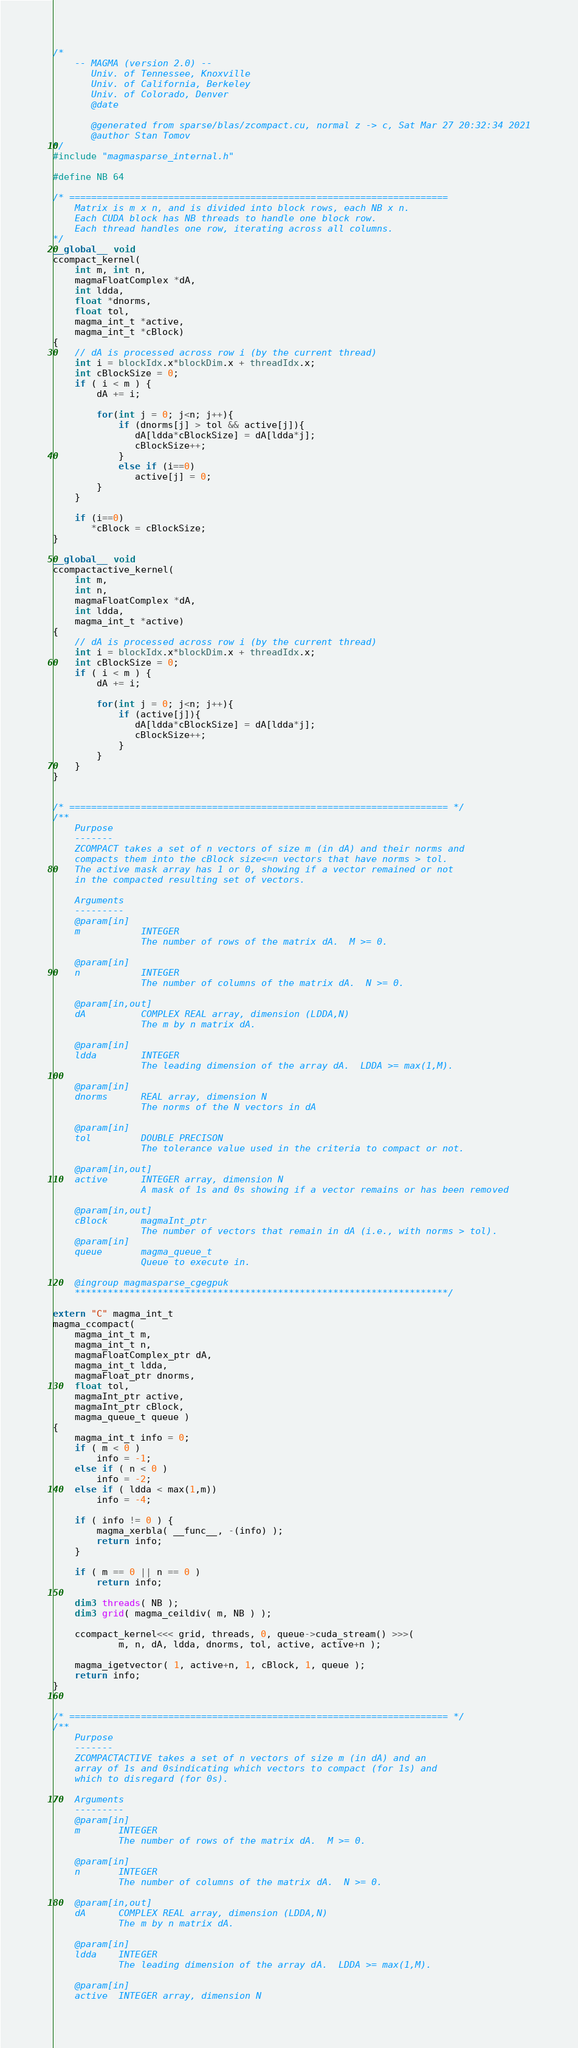<code> <loc_0><loc_0><loc_500><loc_500><_Cuda_>/*
    -- MAGMA (version 2.0) --
       Univ. of Tennessee, Knoxville
       Univ. of California, Berkeley
       Univ. of Colorado, Denver
       @date

       @generated from sparse/blas/zcompact.cu, normal z -> c, Sat Mar 27 20:32:34 2021
       @author Stan Tomov
*/
#include "magmasparse_internal.h"

#define NB 64

/* =====================================================================
    Matrix is m x n, and is divided into block rows, each NB x n.
    Each CUDA block has NB threads to handle one block row.
    Each thread handles one row, iterating across all columns.
*/
__global__ void
ccompact_kernel(
    int m, int n,
    magmaFloatComplex *dA, 
    int ldda,
    float *dnorms, 
    float tol,
    magma_int_t *active, 
    magma_int_t *cBlock)
{
    // dA is processed across row i (by the current thread)
    int i = blockIdx.x*blockDim.x + threadIdx.x;
    int cBlockSize = 0;
    if ( i < m ) {
        dA += i;
        
        for(int j = 0; j<n; j++){
            if (dnorms[j] > tol && active[j]){
               dA[ldda*cBlockSize] = dA[ldda*j];
               cBlockSize++;
            }
            else if (i==0)
               active[j] = 0;
        }
    }

    if (i==0)
       *cBlock = cBlockSize;
}

__global__ void
ccompactactive_kernel(
    int m, 
    int n,
    magmaFloatComplex *dA, 
    int ldda,
    magma_int_t *active)
{
    // dA is processed across row i (by the current thread)
    int i = blockIdx.x*blockDim.x + threadIdx.x;
    int cBlockSize = 0;
    if ( i < m ) {
        dA += i;

        for(int j = 0; j<n; j++){
            if (active[j]){
               dA[ldda*cBlockSize] = dA[ldda*j];
               cBlockSize++;
            }
        }
    }
}


/* ===================================================================== */
/**
    Purpose
    -------
    ZCOMPACT takes a set of n vectors of size m (in dA) and their norms and
    compacts them into the cBlock size<=n vectors that have norms > tol.
    The active mask array has 1 or 0, showing if a vector remained or not
    in the compacted resulting set of vectors.
    
    Arguments
    ---------
    @param[in]
    m           INTEGER
                The number of rows of the matrix dA.  M >= 0.
    
    @param[in]
    n           INTEGER
                The number of columns of the matrix dA.  N >= 0.
    
    @param[in,out]
    dA          COMPLEX REAL array, dimension (LDDA,N)
                The m by n matrix dA.
    
    @param[in]
    ldda        INTEGER
                The leading dimension of the array dA.  LDDA >= max(1,M).
    
    @param[in]
    dnorms      REAL array, dimension N
                The norms of the N vectors in dA

    @param[in]
    tol         DOUBLE PRECISON
                The tolerance value used in the criteria to compact or not.

    @param[in,out]
    active      INTEGER array, dimension N
                A mask of 1s and 0s showing if a vector remains or has been removed
            
    @param[in,out]
    cBlock      magmaInt_ptr
                The number of vectors that remain in dA (i.e., with norms > tol).
    @param[in]
    queue       magma_queue_t
                Queue to execute in.

    @ingroup magmasparse_cgegpuk
    ********************************************************************/

extern "C" magma_int_t
magma_ccompact(
    magma_int_t m, 
    magma_int_t n,
    magmaFloatComplex_ptr dA, 
    magma_int_t ldda,
    magmaFloat_ptr dnorms, 
    float tol, 
    magmaInt_ptr active,
    magmaInt_ptr cBlock,
    magma_queue_t queue )
{
    magma_int_t info = 0;
    if ( m < 0 )
        info = -1;
    else if ( n < 0 )
        info = -2;
    else if ( ldda < max(1,m))
        info = -4;
    
    if ( info != 0 ) {
        magma_xerbla( __func__, -(info) );
        return info;
    }
    
    if ( m == 0 || n == 0 )
        return info;
    
    dim3 threads( NB );
    dim3 grid( magma_ceildiv( m, NB ) );
    
    ccompact_kernel<<< grid, threads, 0, queue->cuda_stream() >>>(
            m, n, dA, ldda, dnorms, tol, active, active+n );

    magma_igetvector( 1, active+n, 1, cBlock, 1, queue );
    return info;
}


/* ===================================================================== */
/**
    Purpose
    -------
    ZCOMPACTACTIVE takes a set of n vectors of size m (in dA) and an
    array of 1s and 0sindicating which vectors to compact (for 1s) and
    which to disregard (for 0s).

    Arguments
    ---------
    @param[in]
    m       INTEGER
            The number of rows of the matrix dA.  M >= 0.

    @param[in]
    n       INTEGER
            The number of columns of the matrix dA.  N >= 0.

    @param[in,out]
    dA      COMPLEX REAL array, dimension (LDDA,N)
            The m by n matrix dA.

    @param[in]
    ldda    INTEGER
            The leading dimension of the array dA.  LDDA >= max(1,M).

    @param[in]
    active  INTEGER array, dimension N</code> 